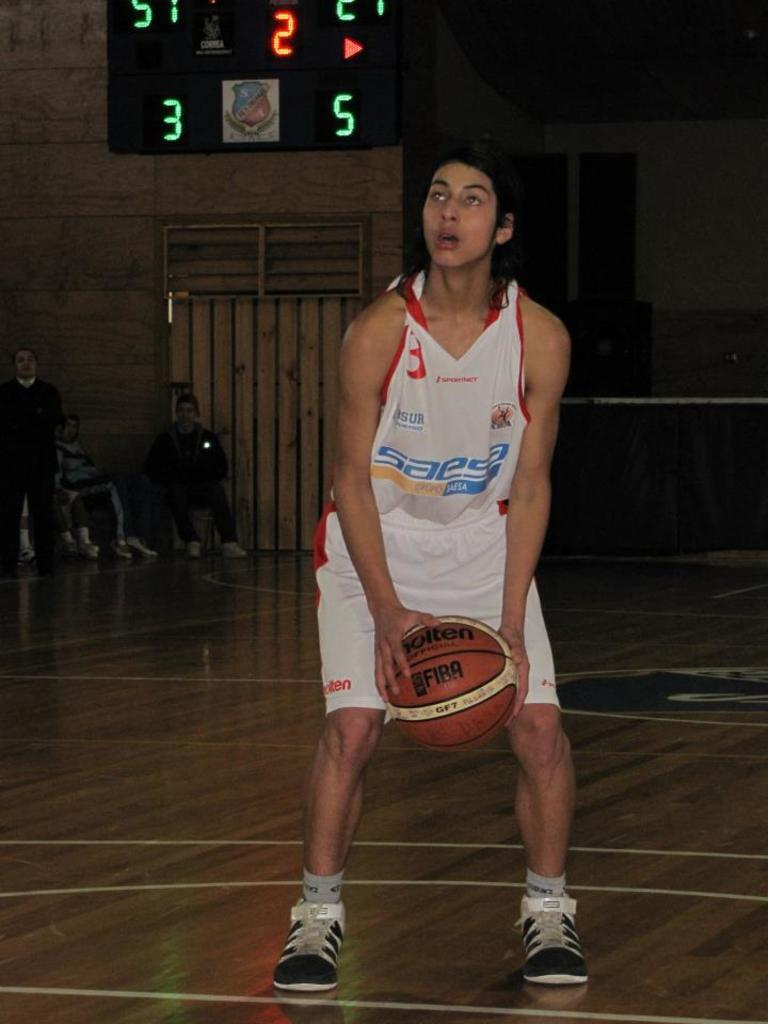<image>
Offer a succinct explanation of the picture presented. The scoreboard behind the player indicates that it is the second quarter. 